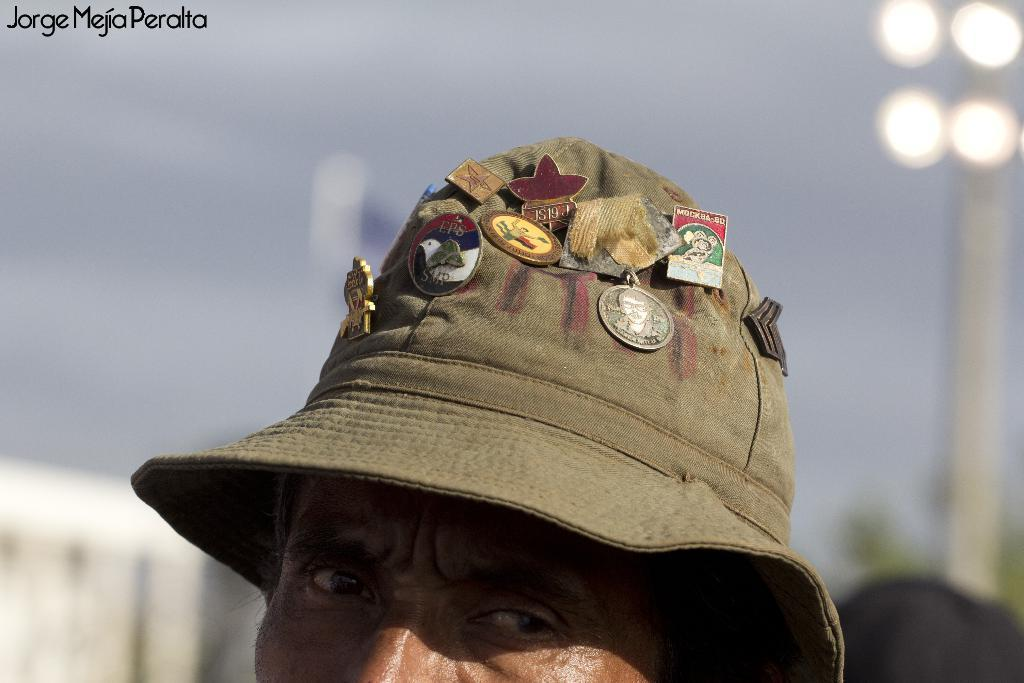What can be seen in the image? There is a person in the image. What is the person wearing? The person is wearing something. What else is visible in the image besides the person? Coins are visible in the image. What color is the background of the image? The background of the image is white. Where is the text located in the image? The text is in the top left corner of the image. How does the person maintain quiet in the image? The image does not provide information about the person's actions or behavior, so we cannot determine if they are maintaining quiet or not. 